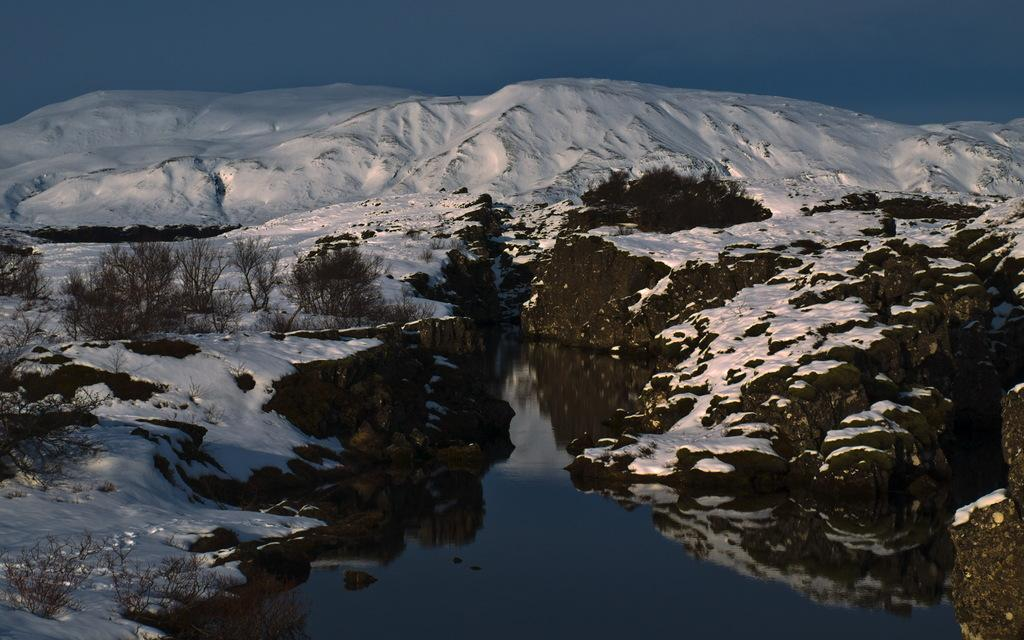What is present in the image that is not solid? There is water visible in the image. What type of vegetation can be seen in the image? There are plants in the image. What geographical feature is covered in snow in the image? There are hills with snow in the image. What is visible at the top of the image? The sky is visible at the top of the image. Can you see any oil dripping from the trees in the image? There is no oil or trees mentioned in the image; it features water, plants, hills with snow, and the sky. 